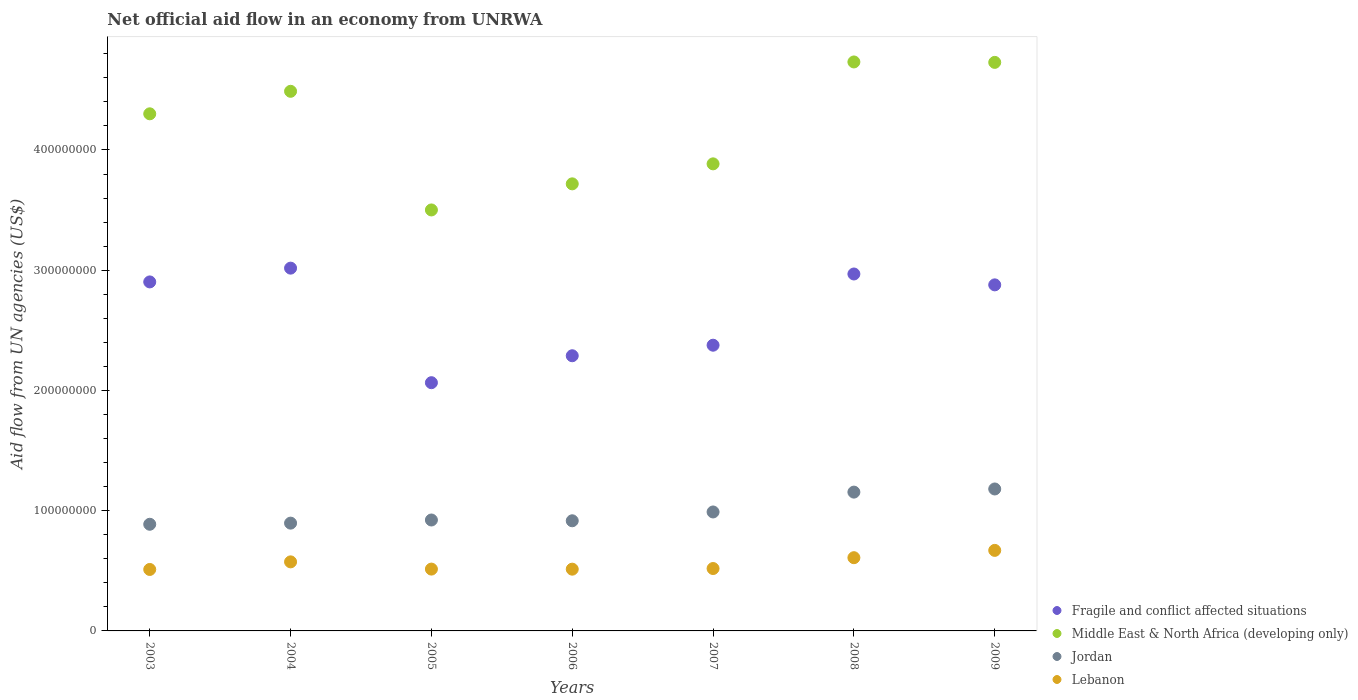What is the net official aid flow in Jordan in 2008?
Offer a terse response. 1.15e+08. Across all years, what is the maximum net official aid flow in Fragile and conflict affected situations?
Your answer should be very brief. 3.02e+08. Across all years, what is the minimum net official aid flow in Jordan?
Keep it short and to the point. 8.87e+07. In which year was the net official aid flow in Jordan maximum?
Keep it short and to the point. 2009. What is the total net official aid flow in Fragile and conflict affected situations in the graph?
Provide a short and direct response. 1.85e+09. What is the difference between the net official aid flow in Middle East & North Africa (developing only) in 2003 and that in 2005?
Ensure brevity in your answer.  8.00e+07. What is the difference between the net official aid flow in Middle East & North Africa (developing only) in 2006 and the net official aid flow in Lebanon in 2005?
Give a very brief answer. 3.20e+08. What is the average net official aid flow in Jordan per year?
Provide a succinct answer. 9.92e+07. In the year 2004, what is the difference between the net official aid flow in Lebanon and net official aid flow in Middle East & North Africa (developing only)?
Your answer should be very brief. -3.91e+08. In how many years, is the net official aid flow in Middle East & North Africa (developing only) greater than 380000000 US$?
Your answer should be compact. 5. What is the ratio of the net official aid flow in Middle East & North Africa (developing only) in 2004 to that in 2009?
Your answer should be compact. 0.95. Is the difference between the net official aid flow in Lebanon in 2003 and 2008 greater than the difference between the net official aid flow in Middle East & North Africa (developing only) in 2003 and 2008?
Make the answer very short. Yes. What is the difference between the highest and the second highest net official aid flow in Middle East & North Africa (developing only)?
Offer a terse response. 3.60e+05. What is the difference between the highest and the lowest net official aid flow in Lebanon?
Keep it short and to the point. 1.59e+07. In how many years, is the net official aid flow in Middle East & North Africa (developing only) greater than the average net official aid flow in Middle East & North Africa (developing only) taken over all years?
Your answer should be very brief. 4. Is it the case that in every year, the sum of the net official aid flow in Fragile and conflict affected situations and net official aid flow in Lebanon  is greater than the sum of net official aid flow in Jordan and net official aid flow in Middle East & North Africa (developing only)?
Make the answer very short. No. Is it the case that in every year, the sum of the net official aid flow in Fragile and conflict affected situations and net official aid flow in Lebanon  is greater than the net official aid flow in Middle East & North Africa (developing only)?
Provide a short and direct response. No. Is the net official aid flow in Lebanon strictly greater than the net official aid flow in Middle East & North Africa (developing only) over the years?
Keep it short and to the point. No. Is the net official aid flow in Middle East & North Africa (developing only) strictly less than the net official aid flow in Lebanon over the years?
Your answer should be very brief. No. How many dotlines are there?
Your answer should be very brief. 4. Are the values on the major ticks of Y-axis written in scientific E-notation?
Ensure brevity in your answer.  No. Does the graph contain any zero values?
Your response must be concise. No. Does the graph contain grids?
Provide a succinct answer. No. Where does the legend appear in the graph?
Offer a very short reply. Bottom right. How many legend labels are there?
Your response must be concise. 4. How are the legend labels stacked?
Offer a very short reply. Vertical. What is the title of the graph?
Provide a short and direct response. Net official aid flow in an economy from UNRWA. Does "Middle East & North Africa (developing only)" appear as one of the legend labels in the graph?
Make the answer very short. Yes. What is the label or title of the Y-axis?
Your response must be concise. Aid flow from UN agencies (US$). What is the Aid flow from UN agencies (US$) in Fragile and conflict affected situations in 2003?
Ensure brevity in your answer.  2.90e+08. What is the Aid flow from UN agencies (US$) in Middle East & North Africa (developing only) in 2003?
Make the answer very short. 4.30e+08. What is the Aid flow from UN agencies (US$) of Jordan in 2003?
Your answer should be compact. 8.87e+07. What is the Aid flow from UN agencies (US$) in Lebanon in 2003?
Your response must be concise. 5.11e+07. What is the Aid flow from UN agencies (US$) of Fragile and conflict affected situations in 2004?
Your response must be concise. 3.02e+08. What is the Aid flow from UN agencies (US$) in Middle East & North Africa (developing only) in 2004?
Provide a short and direct response. 4.49e+08. What is the Aid flow from UN agencies (US$) of Jordan in 2004?
Provide a succinct answer. 8.96e+07. What is the Aid flow from UN agencies (US$) in Lebanon in 2004?
Keep it short and to the point. 5.74e+07. What is the Aid flow from UN agencies (US$) in Fragile and conflict affected situations in 2005?
Ensure brevity in your answer.  2.06e+08. What is the Aid flow from UN agencies (US$) in Middle East & North Africa (developing only) in 2005?
Offer a terse response. 3.50e+08. What is the Aid flow from UN agencies (US$) in Jordan in 2005?
Your answer should be very brief. 9.22e+07. What is the Aid flow from UN agencies (US$) in Lebanon in 2005?
Your answer should be compact. 5.14e+07. What is the Aid flow from UN agencies (US$) of Fragile and conflict affected situations in 2006?
Your response must be concise. 2.29e+08. What is the Aid flow from UN agencies (US$) of Middle East & North Africa (developing only) in 2006?
Your answer should be very brief. 3.72e+08. What is the Aid flow from UN agencies (US$) in Jordan in 2006?
Keep it short and to the point. 9.16e+07. What is the Aid flow from UN agencies (US$) of Lebanon in 2006?
Ensure brevity in your answer.  5.14e+07. What is the Aid flow from UN agencies (US$) in Fragile and conflict affected situations in 2007?
Keep it short and to the point. 2.38e+08. What is the Aid flow from UN agencies (US$) of Middle East & North Africa (developing only) in 2007?
Your answer should be very brief. 3.88e+08. What is the Aid flow from UN agencies (US$) in Jordan in 2007?
Keep it short and to the point. 9.89e+07. What is the Aid flow from UN agencies (US$) in Lebanon in 2007?
Make the answer very short. 5.19e+07. What is the Aid flow from UN agencies (US$) in Fragile and conflict affected situations in 2008?
Your answer should be very brief. 2.97e+08. What is the Aid flow from UN agencies (US$) in Middle East & North Africa (developing only) in 2008?
Make the answer very short. 4.73e+08. What is the Aid flow from UN agencies (US$) of Jordan in 2008?
Keep it short and to the point. 1.15e+08. What is the Aid flow from UN agencies (US$) of Lebanon in 2008?
Your answer should be very brief. 6.09e+07. What is the Aid flow from UN agencies (US$) of Fragile and conflict affected situations in 2009?
Make the answer very short. 2.88e+08. What is the Aid flow from UN agencies (US$) in Middle East & North Africa (developing only) in 2009?
Give a very brief answer. 4.73e+08. What is the Aid flow from UN agencies (US$) of Jordan in 2009?
Offer a terse response. 1.18e+08. What is the Aid flow from UN agencies (US$) in Lebanon in 2009?
Offer a terse response. 6.70e+07. Across all years, what is the maximum Aid flow from UN agencies (US$) in Fragile and conflict affected situations?
Your answer should be compact. 3.02e+08. Across all years, what is the maximum Aid flow from UN agencies (US$) of Middle East & North Africa (developing only)?
Offer a terse response. 4.73e+08. Across all years, what is the maximum Aid flow from UN agencies (US$) in Jordan?
Offer a very short reply. 1.18e+08. Across all years, what is the maximum Aid flow from UN agencies (US$) in Lebanon?
Your answer should be very brief. 6.70e+07. Across all years, what is the minimum Aid flow from UN agencies (US$) in Fragile and conflict affected situations?
Provide a succinct answer. 2.06e+08. Across all years, what is the minimum Aid flow from UN agencies (US$) of Middle East & North Africa (developing only)?
Offer a terse response. 3.50e+08. Across all years, what is the minimum Aid flow from UN agencies (US$) in Jordan?
Your answer should be very brief. 8.87e+07. Across all years, what is the minimum Aid flow from UN agencies (US$) of Lebanon?
Provide a short and direct response. 5.11e+07. What is the total Aid flow from UN agencies (US$) of Fragile and conflict affected situations in the graph?
Provide a succinct answer. 1.85e+09. What is the total Aid flow from UN agencies (US$) of Middle East & North Africa (developing only) in the graph?
Give a very brief answer. 2.94e+09. What is the total Aid flow from UN agencies (US$) of Jordan in the graph?
Offer a terse response. 6.95e+08. What is the total Aid flow from UN agencies (US$) in Lebanon in the graph?
Ensure brevity in your answer.  3.91e+08. What is the difference between the Aid flow from UN agencies (US$) in Fragile and conflict affected situations in 2003 and that in 2004?
Your response must be concise. -1.15e+07. What is the difference between the Aid flow from UN agencies (US$) of Middle East & North Africa (developing only) in 2003 and that in 2004?
Offer a very short reply. -1.87e+07. What is the difference between the Aid flow from UN agencies (US$) in Jordan in 2003 and that in 2004?
Your response must be concise. -9.40e+05. What is the difference between the Aid flow from UN agencies (US$) of Lebanon in 2003 and that in 2004?
Your answer should be compact. -6.32e+06. What is the difference between the Aid flow from UN agencies (US$) of Fragile and conflict affected situations in 2003 and that in 2005?
Provide a short and direct response. 8.38e+07. What is the difference between the Aid flow from UN agencies (US$) of Middle East & North Africa (developing only) in 2003 and that in 2005?
Your response must be concise. 8.00e+07. What is the difference between the Aid flow from UN agencies (US$) in Jordan in 2003 and that in 2005?
Offer a very short reply. -3.55e+06. What is the difference between the Aid flow from UN agencies (US$) of Lebanon in 2003 and that in 2005?
Your answer should be very brief. -3.10e+05. What is the difference between the Aid flow from UN agencies (US$) in Fragile and conflict affected situations in 2003 and that in 2006?
Provide a short and direct response. 6.14e+07. What is the difference between the Aid flow from UN agencies (US$) of Middle East & North Africa (developing only) in 2003 and that in 2006?
Your answer should be compact. 5.82e+07. What is the difference between the Aid flow from UN agencies (US$) of Jordan in 2003 and that in 2006?
Offer a terse response. -2.90e+06. What is the difference between the Aid flow from UN agencies (US$) of Lebanon in 2003 and that in 2006?
Provide a succinct answer. -2.50e+05. What is the difference between the Aid flow from UN agencies (US$) of Fragile and conflict affected situations in 2003 and that in 2007?
Give a very brief answer. 5.26e+07. What is the difference between the Aid flow from UN agencies (US$) of Middle East & North Africa (developing only) in 2003 and that in 2007?
Your answer should be very brief. 4.16e+07. What is the difference between the Aid flow from UN agencies (US$) in Jordan in 2003 and that in 2007?
Your answer should be very brief. -1.02e+07. What is the difference between the Aid flow from UN agencies (US$) in Lebanon in 2003 and that in 2007?
Make the answer very short. -7.80e+05. What is the difference between the Aid flow from UN agencies (US$) of Fragile and conflict affected situations in 2003 and that in 2008?
Give a very brief answer. -6.60e+06. What is the difference between the Aid flow from UN agencies (US$) of Middle East & North Africa (developing only) in 2003 and that in 2008?
Offer a terse response. -4.31e+07. What is the difference between the Aid flow from UN agencies (US$) in Jordan in 2003 and that in 2008?
Your answer should be very brief. -2.67e+07. What is the difference between the Aid flow from UN agencies (US$) in Lebanon in 2003 and that in 2008?
Offer a very short reply. -9.79e+06. What is the difference between the Aid flow from UN agencies (US$) in Fragile and conflict affected situations in 2003 and that in 2009?
Make the answer very short. 2.45e+06. What is the difference between the Aid flow from UN agencies (US$) of Middle East & North Africa (developing only) in 2003 and that in 2009?
Offer a terse response. -4.28e+07. What is the difference between the Aid flow from UN agencies (US$) of Jordan in 2003 and that in 2009?
Keep it short and to the point. -2.94e+07. What is the difference between the Aid flow from UN agencies (US$) in Lebanon in 2003 and that in 2009?
Your response must be concise. -1.59e+07. What is the difference between the Aid flow from UN agencies (US$) in Fragile and conflict affected situations in 2004 and that in 2005?
Give a very brief answer. 9.53e+07. What is the difference between the Aid flow from UN agencies (US$) of Middle East & North Africa (developing only) in 2004 and that in 2005?
Your answer should be very brief. 9.87e+07. What is the difference between the Aid flow from UN agencies (US$) of Jordan in 2004 and that in 2005?
Your response must be concise. -2.61e+06. What is the difference between the Aid flow from UN agencies (US$) of Lebanon in 2004 and that in 2005?
Your answer should be very brief. 6.01e+06. What is the difference between the Aid flow from UN agencies (US$) in Fragile and conflict affected situations in 2004 and that in 2006?
Ensure brevity in your answer.  7.29e+07. What is the difference between the Aid flow from UN agencies (US$) of Middle East & North Africa (developing only) in 2004 and that in 2006?
Provide a succinct answer. 7.70e+07. What is the difference between the Aid flow from UN agencies (US$) of Jordan in 2004 and that in 2006?
Your answer should be compact. -1.96e+06. What is the difference between the Aid flow from UN agencies (US$) of Lebanon in 2004 and that in 2006?
Ensure brevity in your answer.  6.07e+06. What is the difference between the Aid flow from UN agencies (US$) in Fragile and conflict affected situations in 2004 and that in 2007?
Give a very brief answer. 6.41e+07. What is the difference between the Aid flow from UN agencies (US$) of Middle East & North Africa (developing only) in 2004 and that in 2007?
Ensure brevity in your answer.  6.03e+07. What is the difference between the Aid flow from UN agencies (US$) of Jordan in 2004 and that in 2007?
Your response must be concise. -9.29e+06. What is the difference between the Aid flow from UN agencies (US$) in Lebanon in 2004 and that in 2007?
Offer a very short reply. 5.54e+06. What is the difference between the Aid flow from UN agencies (US$) in Fragile and conflict affected situations in 2004 and that in 2008?
Offer a terse response. 4.86e+06. What is the difference between the Aid flow from UN agencies (US$) of Middle East & North Africa (developing only) in 2004 and that in 2008?
Offer a very short reply. -2.44e+07. What is the difference between the Aid flow from UN agencies (US$) in Jordan in 2004 and that in 2008?
Offer a terse response. -2.58e+07. What is the difference between the Aid flow from UN agencies (US$) of Lebanon in 2004 and that in 2008?
Make the answer very short. -3.47e+06. What is the difference between the Aid flow from UN agencies (US$) of Fragile and conflict affected situations in 2004 and that in 2009?
Provide a short and direct response. 1.39e+07. What is the difference between the Aid flow from UN agencies (US$) in Middle East & North Africa (developing only) in 2004 and that in 2009?
Provide a succinct answer. -2.40e+07. What is the difference between the Aid flow from UN agencies (US$) of Jordan in 2004 and that in 2009?
Make the answer very short. -2.84e+07. What is the difference between the Aid flow from UN agencies (US$) of Lebanon in 2004 and that in 2009?
Offer a very short reply. -9.55e+06. What is the difference between the Aid flow from UN agencies (US$) in Fragile and conflict affected situations in 2005 and that in 2006?
Keep it short and to the point. -2.24e+07. What is the difference between the Aid flow from UN agencies (US$) of Middle East & North Africa (developing only) in 2005 and that in 2006?
Offer a terse response. -2.17e+07. What is the difference between the Aid flow from UN agencies (US$) in Jordan in 2005 and that in 2006?
Provide a succinct answer. 6.50e+05. What is the difference between the Aid flow from UN agencies (US$) of Lebanon in 2005 and that in 2006?
Your answer should be very brief. 6.00e+04. What is the difference between the Aid flow from UN agencies (US$) in Fragile and conflict affected situations in 2005 and that in 2007?
Your response must be concise. -3.12e+07. What is the difference between the Aid flow from UN agencies (US$) in Middle East & North Africa (developing only) in 2005 and that in 2007?
Ensure brevity in your answer.  -3.83e+07. What is the difference between the Aid flow from UN agencies (US$) in Jordan in 2005 and that in 2007?
Give a very brief answer. -6.68e+06. What is the difference between the Aid flow from UN agencies (US$) of Lebanon in 2005 and that in 2007?
Ensure brevity in your answer.  -4.70e+05. What is the difference between the Aid flow from UN agencies (US$) of Fragile and conflict affected situations in 2005 and that in 2008?
Offer a very short reply. -9.04e+07. What is the difference between the Aid flow from UN agencies (US$) of Middle East & North Africa (developing only) in 2005 and that in 2008?
Your answer should be very brief. -1.23e+08. What is the difference between the Aid flow from UN agencies (US$) of Jordan in 2005 and that in 2008?
Offer a very short reply. -2.32e+07. What is the difference between the Aid flow from UN agencies (US$) in Lebanon in 2005 and that in 2008?
Ensure brevity in your answer.  -9.48e+06. What is the difference between the Aid flow from UN agencies (US$) of Fragile and conflict affected situations in 2005 and that in 2009?
Offer a terse response. -8.14e+07. What is the difference between the Aid flow from UN agencies (US$) in Middle East & North Africa (developing only) in 2005 and that in 2009?
Your response must be concise. -1.23e+08. What is the difference between the Aid flow from UN agencies (US$) of Jordan in 2005 and that in 2009?
Provide a succinct answer. -2.58e+07. What is the difference between the Aid flow from UN agencies (US$) in Lebanon in 2005 and that in 2009?
Provide a short and direct response. -1.56e+07. What is the difference between the Aid flow from UN agencies (US$) of Fragile and conflict affected situations in 2006 and that in 2007?
Your answer should be compact. -8.77e+06. What is the difference between the Aid flow from UN agencies (US$) of Middle East & North Africa (developing only) in 2006 and that in 2007?
Your response must be concise. -1.66e+07. What is the difference between the Aid flow from UN agencies (US$) in Jordan in 2006 and that in 2007?
Make the answer very short. -7.33e+06. What is the difference between the Aid flow from UN agencies (US$) of Lebanon in 2006 and that in 2007?
Provide a succinct answer. -5.30e+05. What is the difference between the Aid flow from UN agencies (US$) of Fragile and conflict affected situations in 2006 and that in 2008?
Your response must be concise. -6.80e+07. What is the difference between the Aid flow from UN agencies (US$) in Middle East & North Africa (developing only) in 2006 and that in 2008?
Give a very brief answer. -1.01e+08. What is the difference between the Aid flow from UN agencies (US$) in Jordan in 2006 and that in 2008?
Keep it short and to the point. -2.38e+07. What is the difference between the Aid flow from UN agencies (US$) in Lebanon in 2006 and that in 2008?
Your response must be concise. -9.54e+06. What is the difference between the Aid flow from UN agencies (US$) in Fragile and conflict affected situations in 2006 and that in 2009?
Offer a very short reply. -5.90e+07. What is the difference between the Aid flow from UN agencies (US$) of Middle East & North Africa (developing only) in 2006 and that in 2009?
Keep it short and to the point. -1.01e+08. What is the difference between the Aid flow from UN agencies (US$) in Jordan in 2006 and that in 2009?
Offer a very short reply. -2.64e+07. What is the difference between the Aid flow from UN agencies (US$) in Lebanon in 2006 and that in 2009?
Your answer should be compact. -1.56e+07. What is the difference between the Aid flow from UN agencies (US$) in Fragile and conflict affected situations in 2007 and that in 2008?
Offer a very short reply. -5.92e+07. What is the difference between the Aid flow from UN agencies (US$) of Middle East & North Africa (developing only) in 2007 and that in 2008?
Your answer should be very brief. -8.48e+07. What is the difference between the Aid flow from UN agencies (US$) of Jordan in 2007 and that in 2008?
Make the answer very short. -1.65e+07. What is the difference between the Aid flow from UN agencies (US$) of Lebanon in 2007 and that in 2008?
Offer a very short reply. -9.01e+06. What is the difference between the Aid flow from UN agencies (US$) in Fragile and conflict affected situations in 2007 and that in 2009?
Provide a short and direct response. -5.02e+07. What is the difference between the Aid flow from UN agencies (US$) in Middle East & North Africa (developing only) in 2007 and that in 2009?
Offer a very short reply. -8.44e+07. What is the difference between the Aid flow from UN agencies (US$) of Jordan in 2007 and that in 2009?
Keep it short and to the point. -1.91e+07. What is the difference between the Aid flow from UN agencies (US$) of Lebanon in 2007 and that in 2009?
Give a very brief answer. -1.51e+07. What is the difference between the Aid flow from UN agencies (US$) in Fragile and conflict affected situations in 2008 and that in 2009?
Your answer should be very brief. 9.05e+06. What is the difference between the Aid flow from UN agencies (US$) in Jordan in 2008 and that in 2009?
Provide a short and direct response. -2.61e+06. What is the difference between the Aid flow from UN agencies (US$) in Lebanon in 2008 and that in 2009?
Ensure brevity in your answer.  -6.08e+06. What is the difference between the Aid flow from UN agencies (US$) of Fragile and conflict affected situations in 2003 and the Aid flow from UN agencies (US$) of Middle East & North Africa (developing only) in 2004?
Your response must be concise. -1.59e+08. What is the difference between the Aid flow from UN agencies (US$) in Fragile and conflict affected situations in 2003 and the Aid flow from UN agencies (US$) in Jordan in 2004?
Ensure brevity in your answer.  2.01e+08. What is the difference between the Aid flow from UN agencies (US$) of Fragile and conflict affected situations in 2003 and the Aid flow from UN agencies (US$) of Lebanon in 2004?
Ensure brevity in your answer.  2.33e+08. What is the difference between the Aid flow from UN agencies (US$) in Middle East & North Africa (developing only) in 2003 and the Aid flow from UN agencies (US$) in Jordan in 2004?
Keep it short and to the point. 3.40e+08. What is the difference between the Aid flow from UN agencies (US$) of Middle East & North Africa (developing only) in 2003 and the Aid flow from UN agencies (US$) of Lebanon in 2004?
Offer a very short reply. 3.73e+08. What is the difference between the Aid flow from UN agencies (US$) of Jordan in 2003 and the Aid flow from UN agencies (US$) of Lebanon in 2004?
Provide a short and direct response. 3.13e+07. What is the difference between the Aid flow from UN agencies (US$) of Fragile and conflict affected situations in 2003 and the Aid flow from UN agencies (US$) of Middle East & North Africa (developing only) in 2005?
Ensure brevity in your answer.  -5.99e+07. What is the difference between the Aid flow from UN agencies (US$) of Fragile and conflict affected situations in 2003 and the Aid flow from UN agencies (US$) of Jordan in 2005?
Your response must be concise. 1.98e+08. What is the difference between the Aid flow from UN agencies (US$) in Fragile and conflict affected situations in 2003 and the Aid flow from UN agencies (US$) in Lebanon in 2005?
Offer a terse response. 2.39e+08. What is the difference between the Aid flow from UN agencies (US$) of Middle East & North Africa (developing only) in 2003 and the Aid flow from UN agencies (US$) of Jordan in 2005?
Make the answer very short. 3.38e+08. What is the difference between the Aid flow from UN agencies (US$) in Middle East & North Africa (developing only) in 2003 and the Aid flow from UN agencies (US$) in Lebanon in 2005?
Keep it short and to the point. 3.79e+08. What is the difference between the Aid flow from UN agencies (US$) in Jordan in 2003 and the Aid flow from UN agencies (US$) in Lebanon in 2005?
Offer a very short reply. 3.73e+07. What is the difference between the Aid flow from UN agencies (US$) in Fragile and conflict affected situations in 2003 and the Aid flow from UN agencies (US$) in Middle East & North Africa (developing only) in 2006?
Offer a terse response. -8.16e+07. What is the difference between the Aid flow from UN agencies (US$) in Fragile and conflict affected situations in 2003 and the Aid flow from UN agencies (US$) in Jordan in 2006?
Ensure brevity in your answer.  1.99e+08. What is the difference between the Aid flow from UN agencies (US$) in Fragile and conflict affected situations in 2003 and the Aid flow from UN agencies (US$) in Lebanon in 2006?
Provide a short and direct response. 2.39e+08. What is the difference between the Aid flow from UN agencies (US$) in Middle East & North Africa (developing only) in 2003 and the Aid flow from UN agencies (US$) in Jordan in 2006?
Keep it short and to the point. 3.38e+08. What is the difference between the Aid flow from UN agencies (US$) of Middle East & North Africa (developing only) in 2003 and the Aid flow from UN agencies (US$) of Lebanon in 2006?
Your answer should be compact. 3.79e+08. What is the difference between the Aid flow from UN agencies (US$) in Jordan in 2003 and the Aid flow from UN agencies (US$) in Lebanon in 2006?
Make the answer very short. 3.73e+07. What is the difference between the Aid flow from UN agencies (US$) in Fragile and conflict affected situations in 2003 and the Aid flow from UN agencies (US$) in Middle East & North Africa (developing only) in 2007?
Your answer should be compact. -9.82e+07. What is the difference between the Aid flow from UN agencies (US$) of Fragile and conflict affected situations in 2003 and the Aid flow from UN agencies (US$) of Jordan in 2007?
Give a very brief answer. 1.91e+08. What is the difference between the Aid flow from UN agencies (US$) of Fragile and conflict affected situations in 2003 and the Aid flow from UN agencies (US$) of Lebanon in 2007?
Ensure brevity in your answer.  2.38e+08. What is the difference between the Aid flow from UN agencies (US$) in Middle East & North Africa (developing only) in 2003 and the Aid flow from UN agencies (US$) in Jordan in 2007?
Offer a very short reply. 3.31e+08. What is the difference between the Aid flow from UN agencies (US$) in Middle East & North Africa (developing only) in 2003 and the Aid flow from UN agencies (US$) in Lebanon in 2007?
Give a very brief answer. 3.78e+08. What is the difference between the Aid flow from UN agencies (US$) in Jordan in 2003 and the Aid flow from UN agencies (US$) in Lebanon in 2007?
Offer a very short reply. 3.68e+07. What is the difference between the Aid flow from UN agencies (US$) in Fragile and conflict affected situations in 2003 and the Aid flow from UN agencies (US$) in Middle East & North Africa (developing only) in 2008?
Keep it short and to the point. -1.83e+08. What is the difference between the Aid flow from UN agencies (US$) of Fragile and conflict affected situations in 2003 and the Aid flow from UN agencies (US$) of Jordan in 2008?
Your response must be concise. 1.75e+08. What is the difference between the Aid flow from UN agencies (US$) in Fragile and conflict affected situations in 2003 and the Aid flow from UN agencies (US$) in Lebanon in 2008?
Your answer should be very brief. 2.29e+08. What is the difference between the Aid flow from UN agencies (US$) of Middle East & North Africa (developing only) in 2003 and the Aid flow from UN agencies (US$) of Jordan in 2008?
Give a very brief answer. 3.15e+08. What is the difference between the Aid flow from UN agencies (US$) of Middle East & North Africa (developing only) in 2003 and the Aid flow from UN agencies (US$) of Lebanon in 2008?
Your answer should be compact. 3.69e+08. What is the difference between the Aid flow from UN agencies (US$) of Jordan in 2003 and the Aid flow from UN agencies (US$) of Lebanon in 2008?
Offer a terse response. 2.78e+07. What is the difference between the Aid flow from UN agencies (US$) in Fragile and conflict affected situations in 2003 and the Aid flow from UN agencies (US$) in Middle East & North Africa (developing only) in 2009?
Your answer should be compact. -1.83e+08. What is the difference between the Aid flow from UN agencies (US$) in Fragile and conflict affected situations in 2003 and the Aid flow from UN agencies (US$) in Jordan in 2009?
Provide a succinct answer. 1.72e+08. What is the difference between the Aid flow from UN agencies (US$) in Fragile and conflict affected situations in 2003 and the Aid flow from UN agencies (US$) in Lebanon in 2009?
Ensure brevity in your answer.  2.23e+08. What is the difference between the Aid flow from UN agencies (US$) in Middle East & North Africa (developing only) in 2003 and the Aid flow from UN agencies (US$) in Jordan in 2009?
Make the answer very short. 3.12e+08. What is the difference between the Aid flow from UN agencies (US$) in Middle East & North Africa (developing only) in 2003 and the Aid flow from UN agencies (US$) in Lebanon in 2009?
Provide a short and direct response. 3.63e+08. What is the difference between the Aid flow from UN agencies (US$) in Jordan in 2003 and the Aid flow from UN agencies (US$) in Lebanon in 2009?
Your answer should be compact. 2.17e+07. What is the difference between the Aid flow from UN agencies (US$) of Fragile and conflict affected situations in 2004 and the Aid flow from UN agencies (US$) of Middle East & North Africa (developing only) in 2005?
Provide a succinct answer. -4.84e+07. What is the difference between the Aid flow from UN agencies (US$) in Fragile and conflict affected situations in 2004 and the Aid flow from UN agencies (US$) in Jordan in 2005?
Your answer should be very brief. 2.09e+08. What is the difference between the Aid flow from UN agencies (US$) in Fragile and conflict affected situations in 2004 and the Aid flow from UN agencies (US$) in Lebanon in 2005?
Keep it short and to the point. 2.50e+08. What is the difference between the Aid flow from UN agencies (US$) in Middle East & North Africa (developing only) in 2004 and the Aid flow from UN agencies (US$) in Jordan in 2005?
Give a very brief answer. 3.57e+08. What is the difference between the Aid flow from UN agencies (US$) in Middle East & North Africa (developing only) in 2004 and the Aid flow from UN agencies (US$) in Lebanon in 2005?
Offer a terse response. 3.97e+08. What is the difference between the Aid flow from UN agencies (US$) of Jordan in 2004 and the Aid flow from UN agencies (US$) of Lebanon in 2005?
Give a very brief answer. 3.82e+07. What is the difference between the Aid flow from UN agencies (US$) in Fragile and conflict affected situations in 2004 and the Aid flow from UN agencies (US$) in Middle East & North Africa (developing only) in 2006?
Provide a short and direct response. -7.01e+07. What is the difference between the Aid flow from UN agencies (US$) in Fragile and conflict affected situations in 2004 and the Aid flow from UN agencies (US$) in Jordan in 2006?
Ensure brevity in your answer.  2.10e+08. What is the difference between the Aid flow from UN agencies (US$) in Fragile and conflict affected situations in 2004 and the Aid flow from UN agencies (US$) in Lebanon in 2006?
Keep it short and to the point. 2.50e+08. What is the difference between the Aid flow from UN agencies (US$) of Middle East & North Africa (developing only) in 2004 and the Aid flow from UN agencies (US$) of Jordan in 2006?
Offer a terse response. 3.57e+08. What is the difference between the Aid flow from UN agencies (US$) of Middle East & North Africa (developing only) in 2004 and the Aid flow from UN agencies (US$) of Lebanon in 2006?
Your answer should be compact. 3.97e+08. What is the difference between the Aid flow from UN agencies (US$) in Jordan in 2004 and the Aid flow from UN agencies (US$) in Lebanon in 2006?
Give a very brief answer. 3.83e+07. What is the difference between the Aid flow from UN agencies (US$) of Fragile and conflict affected situations in 2004 and the Aid flow from UN agencies (US$) of Middle East & North Africa (developing only) in 2007?
Ensure brevity in your answer.  -8.67e+07. What is the difference between the Aid flow from UN agencies (US$) in Fragile and conflict affected situations in 2004 and the Aid flow from UN agencies (US$) in Jordan in 2007?
Offer a terse response. 2.03e+08. What is the difference between the Aid flow from UN agencies (US$) of Fragile and conflict affected situations in 2004 and the Aid flow from UN agencies (US$) of Lebanon in 2007?
Your response must be concise. 2.50e+08. What is the difference between the Aid flow from UN agencies (US$) of Middle East & North Africa (developing only) in 2004 and the Aid flow from UN agencies (US$) of Jordan in 2007?
Ensure brevity in your answer.  3.50e+08. What is the difference between the Aid flow from UN agencies (US$) in Middle East & North Africa (developing only) in 2004 and the Aid flow from UN agencies (US$) in Lebanon in 2007?
Your answer should be compact. 3.97e+08. What is the difference between the Aid flow from UN agencies (US$) in Jordan in 2004 and the Aid flow from UN agencies (US$) in Lebanon in 2007?
Offer a terse response. 3.78e+07. What is the difference between the Aid flow from UN agencies (US$) of Fragile and conflict affected situations in 2004 and the Aid flow from UN agencies (US$) of Middle East & North Africa (developing only) in 2008?
Provide a succinct answer. -1.71e+08. What is the difference between the Aid flow from UN agencies (US$) of Fragile and conflict affected situations in 2004 and the Aid flow from UN agencies (US$) of Jordan in 2008?
Your answer should be compact. 1.86e+08. What is the difference between the Aid flow from UN agencies (US$) of Fragile and conflict affected situations in 2004 and the Aid flow from UN agencies (US$) of Lebanon in 2008?
Provide a succinct answer. 2.41e+08. What is the difference between the Aid flow from UN agencies (US$) of Middle East & North Africa (developing only) in 2004 and the Aid flow from UN agencies (US$) of Jordan in 2008?
Provide a succinct answer. 3.33e+08. What is the difference between the Aid flow from UN agencies (US$) of Middle East & North Africa (developing only) in 2004 and the Aid flow from UN agencies (US$) of Lebanon in 2008?
Offer a very short reply. 3.88e+08. What is the difference between the Aid flow from UN agencies (US$) in Jordan in 2004 and the Aid flow from UN agencies (US$) in Lebanon in 2008?
Ensure brevity in your answer.  2.87e+07. What is the difference between the Aid flow from UN agencies (US$) of Fragile and conflict affected situations in 2004 and the Aid flow from UN agencies (US$) of Middle East & North Africa (developing only) in 2009?
Your response must be concise. -1.71e+08. What is the difference between the Aid flow from UN agencies (US$) in Fragile and conflict affected situations in 2004 and the Aid flow from UN agencies (US$) in Jordan in 2009?
Keep it short and to the point. 1.84e+08. What is the difference between the Aid flow from UN agencies (US$) of Fragile and conflict affected situations in 2004 and the Aid flow from UN agencies (US$) of Lebanon in 2009?
Give a very brief answer. 2.35e+08. What is the difference between the Aid flow from UN agencies (US$) of Middle East & North Africa (developing only) in 2004 and the Aid flow from UN agencies (US$) of Jordan in 2009?
Keep it short and to the point. 3.31e+08. What is the difference between the Aid flow from UN agencies (US$) of Middle East & North Africa (developing only) in 2004 and the Aid flow from UN agencies (US$) of Lebanon in 2009?
Make the answer very short. 3.82e+08. What is the difference between the Aid flow from UN agencies (US$) in Jordan in 2004 and the Aid flow from UN agencies (US$) in Lebanon in 2009?
Offer a very short reply. 2.27e+07. What is the difference between the Aid flow from UN agencies (US$) of Fragile and conflict affected situations in 2005 and the Aid flow from UN agencies (US$) of Middle East & North Africa (developing only) in 2006?
Offer a very short reply. -1.65e+08. What is the difference between the Aid flow from UN agencies (US$) in Fragile and conflict affected situations in 2005 and the Aid flow from UN agencies (US$) in Jordan in 2006?
Give a very brief answer. 1.15e+08. What is the difference between the Aid flow from UN agencies (US$) in Fragile and conflict affected situations in 2005 and the Aid flow from UN agencies (US$) in Lebanon in 2006?
Your answer should be compact. 1.55e+08. What is the difference between the Aid flow from UN agencies (US$) in Middle East & North Africa (developing only) in 2005 and the Aid flow from UN agencies (US$) in Jordan in 2006?
Your answer should be compact. 2.59e+08. What is the difference between the Aid flow from UN agencies (US$) in Middle East & North Africa (developing only) in 2005 and the Aid flow from UN agencies (US$) in Lebanon in 2006?
Keep it short and to the point. 2.99e+08. What is the difference between the Aid flow from UN agencies (US$) in Jordan in 2005 and the Aid flow from UN agencies (US$) in Lebanon in 2006?
Keep it short and to the point. 4.09e+07. What is the difference between the Aid flow from UN agencies (US$) of Fragile and conflict affected situations in 2005 and the Aid flow from UN agencies (US$) of Middle East & North Africa (developing only) in 2007?
Keep it short and to the point. -1.82e+08. What is the difference between the Aid flow from UN agencies (US$) of Fragile and conflict affected situations in 2005 and the Aid flow from UN agencies (US$) of Jordan in 2007?
Your answer should be very brief. 1.08e+08. What is the difference between the Aid flow from UN agencies (US$) in Fragile and conflict affected situations in 2005 and the Aid flow from UN agencies (US$) in Lebanon in 2007?
Provide a short and direct response. 1.55e+08. What is the difference between the Aid flow from UN agencies (US$) in Middle East & North Africa (developing only) in 2005 and the Aid flow from UN agencies (US$) in Jordan in 2007?
Your response must be concise. 2.51e+08. What is the difference between the Aid flow from UN agencies (US$) of Middle East & North Africa (developing only) in 2005 and the Aid flow from UN agencies (US$) of Lebanon in 2007?
Provide a succinct answer. 2.98e+08. What is the difference between the Aid flow from UN agencies (US$) in Jordan in 2005 and the Aid flow from UN agencies (US$) in Lebanon in 2007?
Provide a short and direct response. 4.04e+07. What is the difference between the Aid flow from UN agencies (US$) in Fragile and conflict affected situations in 2005 and the Aid flow from UN agencies (US$) in Middle East & North Africa (developing only) in 2008?
Your answer should be compact. -2.67e+08. What is the difference between the Aid flow from UN agencies (US$) of Fragile and conflict affected situations in 2005 and the Aid flow from UN agencies (US$) of Jordan in 2008?
Your response must be concise. 9.10e+07. What is the difference between the Aid flow from UN agencies (US$) of Fragile and conflict affected situations in 2005 and the Aid flow from UN agencies (US$) of Lebanon in 2008?
Your answer should be very brief. 1.46e+08. What is the difference between the Aid flow from UN agencies (US$) of Middle East & North Africa (developing only) in 2005 and the Aid flow from UN agencies (US$) of Jordan in 2008?
Keep it short and to the point. 2.35e+08. What is the difference between the Aid flow from UN agencies (US$) of Middle East & North Africa (developing only) in 2005 and the Aid flow from UN agencies (US$) of Lebanon in 2008?
Provide a succinct answer. 2.89e+08. What is the difference between the Aid flow from UN agencies (US$) of Jordan in 2005 and the Aid flow from UN agencies (US$) of Lebanon in 2008?
Your response must be concise. 3.14e+07. What is the difference between the Aid flow from UN agencies (US$) in Fragile and conflict affected situations in 2005 and the Aid flow from UN agencies (US$) in Middle East & North Africa (developing only) in 2009?
Your answer should be compact. -2.66e+08. What is the difference between the Aid flow from UN agencies (US$) in Fragile and conflict affected situations in 2005 and the Aid flow from UN agencies (US$) in Jordan in 2009?
Provide a short and direct response. 8.84e+07. What is the difference between the Aid flow from UN agencies (US$) in Fragile and conflict affected situations in 2005 and the Aid flow from UN agencies (US$) in Lebanon in 2009?
Your answer should be very brief. 1.39e+08. What is the difference between the Aid flow from UN agencies (US$) of Middle East & North Africa (developing only) in 2005 and the Aid flow from UN agencies (US$) of Jordan in 2009?
Your response must be concise. 2.32e+08. What is the difference between the Aid flow from UN agencies (US$) in Middle East & North Africa (developing only) in 2005 and the Aid flow from UN agencies (US$) in Lebanon in 2009?
Offer a terse response. 2.83e+08. What is the difference between the Aid flow from UN agencies (US$) of Jordan in 2005 and the Aid flow from UN agencies (US$) of Lebanon in 2009?
Ensure brevity in your answer.  2.53e+07. What is the difference between the Aid flow from UN agencies (US$) in Fragile and conflict affected situations in 2006 and the Aid flow from UN agencies (US$) in Middle East & North Africa (developing only) in 2007?
Offer a terse response. -1.60e+08. What is the difference between the Aid flow from UN agencies (US$) in Fragile and conflict affected situations in 2006 and the Aid flow from UN agencies (US$) in Jordan in 2007?
Provide a short and direct response. 1.30e+08. What is the difference between the Aid flow from UN agencies (US$) of Fragile and conflict affected situations in 2006 and the Aid flow from UN agencies (US$) of Lebanon in 2007?
Provide a succinct answer. 1.77e+08. What is the difference between the Aid flow from UN agencies (US$) of Middle East & North Africa (developing only) in 2006 and the Aid flow from UN agencies (US$) of Jordan in 2007?
Your response must be concise. 2.73e+08. What is the difference between the Aid flow from UN agencies (US$) of Middle East & North Africa (developing only) in 2006 and the Aid flow from UN agencies (US$) of Lebanon in 2007?
Provide a short and direct response. 3.20e+08. What is the difference between the Aid flow from UN agencies (US$) in Jordan in 2006 and the Aid flow from UN agencies (US$) in Lebanon in 2007?
Keep it short and to the point. 3.97e+07. What is the difference between the Aid flow from UN agencies (US$) in Fragile and conflict affected situations in 2006 and the Aid flow from UN agencies (US$) in Middle East & North Africa (developing only) in 2008?
Your answer should be very brief. -2.44e+08. What is the difference between the Aid flow from UN agencies (US$) in Fragile and conflict affected situations in 2006 and the Aid flow from UN agencies (US$) in Jordan in 2008?
Provide a succinct answer. 1.13e+08. What is the difference between the Aid flow from UN agencies (US$) of Fragile and conflict affected situations in 2006 and the Aid flow from UN agencies (US$) of Lebanon in 2008?
Provide a short and direct response. 1.68e+08. What is the difference between the Aid flow from UN agencies (US$) of Middle East & North Africa (developing only) in 2006 and the Aid flow from UN agencies (US$) of Jordan in 2008?
Your answer should be very brief. 2.56e+08. What is the difference between the Aid flow from UN agencies (US$) of Middle East & North Africa (developing only) in 2006 and the Aid flow from UN agencies (US$) of Lebanon in 2008?
Offer a very short reply. 3.11e+08. What is the difference between the Aid flow from UN agencies (US$) of Jordan in 2006 and the Aid flow from UN agencies (US$) of Lebanon in 2008?
Offer a terse response. 3.07e+07. What is the difference between the Aid flow from UN agencies (US$) in Fragile and conflict affected situations in 2006 and the Aid flow from UN agencies (US$) in Middle East & North Africa (developing only) in 2009?
Offer a terse response. -2.44e+08. What is the difference between the Aid flow from UN agencies (US$) of Fragile and conflict affected situations in 2006 and the Aid flow from UN agencies (US$) of Jordan in 2009?
Offer a very short reply. 1.11e+08. What is the difference between the Aid flow from UN agencies (US$) in Fragile and conflict affected situations in 2006 and the Aid flow from UN agencies (US$) in Lebanon in 2009?
Your response must be concise. 1.62e+08. What is the difference between the Aid flow from UN agencies (US$) in Middle East & North Africa (developing only) in 2006 and the Aid flow from UN agencies (US$) in Jordan in 2009?
Offer a terse response. 2.54e+08. What is the difference between the Aid flow from UN agencies (US$) in Middle East & North Africa (developing only) in 2006 and the Aid flow from UN agencies (US$) in Lebanon in 2009?
Your response must be concise. 3.05e+08. What is the difference between the Aid flow from UN agencies (US$) of Jordan in 2006 and the Aid flow from UN agencies (US$) of Lebanon in 2009?
Keep it short and to the point. 2.46e+07. What is the difference between the Aid flow from UN agencies (US$) of Fragile and conflict affected situations in 2007 and the Aid flow from UN agencies (US$) of Middle East & North Africa (developing only) in 2008?
Make the answer very short. -2.36e+08. What is the difference between the Aid flow from UN agencies (US$) of Fragile and conflict affected situations in 2007 and the Aid flow from UN agencies (US$) of Jordan in 2008?
Make the answer very short. 1.22e+08. What is the difference between the Aid flow from UN agencies (US$) in Fragile and conflict affected situations in 2007 and the Aid flow from UN agencies (US$) in Lebanon in 2008?
Your response must be concise. 1.77e+08. What is the difference between the Aid flow from UN agencies (US$) of Middle East & North Africa (developing only) in 2007 and the Aid flow from UN agencies (US$) of Jordan in 2008?
Offer a very short reply. 2.73e+08. What is the difference between the Aid flow from UN agencies (US$) in Middle East & North Africa (developing only) in 2007 and the Aid flow from UN agencies (US$) in Lebanon in 2008?
Ensure brevity in your answer.  3.28e+08. What is the difference between the Aid flow from UN agencies (US$) in Jordan in 2007 and the Aid flow from UN agencies (US$) in Lebanon in 2008?
Provide a short and direct response. 3.80e+07. What is the difference between the Aid flow from UN agencies (US$) in Fragile and conflict affected situations in 2007 and the Aid flow from UN agencies (US$) in Middle East & North Africa (developing only) in 2009?
Your answer should be compact. -2.35e+08. What is the difference between the Aid flow from UN agencies (US$) of Fragile and conflict affected situations in 2007 and the Aid flow from UN agencies (US$) of Jordan in 2009?
Ensure brevity in your answer.  1.20e+08. What is the difference between the Aid flow from UN agencies (US$) in Fragile and conflict affected situations in 2007 and the Aid flow from UN agencies (US$) in Lebanon in 2009?
Make the answer very short. 1.71e+08. What is the difference between the Aid flow from UN agencies (US$) of Middle East & North Africa (developing only) in 2007 and the Aid flow from UN agencies (US$) of Jordan in 2009?
Offer a very short reply. 2.70e+08. What is the difference between the Aid flow from UN agencies (US$) in Middle East & North Africa (developing only) in 2007 and the Aid flow from UN agencies (US$) in Lebanon in 2009?
Offer a terse response. 3.21e+08. What is the difference between the Aid flow from UN agencies (US$) in Jordan in 2007 and the Aid flow from UN agencies (US$) in Lebanon in 2009?
Make the answer very short. 3.20e+07. What is the difference between the Aid flow from UN agencies (US$) of Fragile and conflict affected situations in 2008 and the Aid flow from UN agencies (US$) of Middle East & North Africa (developing only) in 2009?
Your response must be concise. -1.76e+08. What is the difference between the Aid flow from UN agencies (US$) in Fragile and conflict affected situations in 2008 and the Aid flow from UN agencies (US$) in Jordan in 2009?
Provide a succinct answer. 1.79e+08. What is the difference between the Aid flow from UN agencies (US$) of Fragile and conflict affected situations in 2008 and the Aid flow from UN agencies (US$) of Lebanon in 2009?
Ensure brevity in your answer.  2.30e+08. What is the difference between the Aid flow from UN agencies (US$) of Middle East & North Africa (developing only) in 2008 and the Aid flow from UN agencies (US$) of Jordan in 2009?
Make the answer very short. 3.55e+08. What is the difference between the Aid flow from UN agencies (US$) in Middle East & North Africa (developing only) in 2008 and the Aid flow from UN agencies (US$) in Lebanon in 2009?
Offer a very short reply. 4.06e+08. What is the difference between the Aid flow from UN agencies (US$) in Jordan in 2008 and the Aid flow from UN agencies (US$) in Lebanon in 2009?
Ensure brevity in your answer.  4.85e+07. What is the average Aid flow from UN agencies (US$) of Fragile and conflict affected situations per year?
Offer a terse response. 2.64e+08. What is the average Aid flow from UN agencies (US$) in Middle East & North Africa (developing only) per year?
Give a very brief answer. 4.19e+08. What is the average Aid flow from UN agencies (US$) in Jordan per year?
Make the answer very short. 9.92e+07. What is the average Aid flow from UN agencies (US$) of Lebanon per year?
Give a very brief answer. 5.59e+07. In the year 2003, what is the difference between the Aid flow from UN agencies (US$) in Fragile and conflict affected situations and Aid flow from UN agencies (US$) in Middle East & North Africa (developing only)?
Your answer should be very brief. -1.40e+08. In the year 2003, what is the difference between the Aid flow from UN agencies (US$) in Fragile and conflict affected situations and Aid flow from UN agencies (US$) in Jordan?
Give a very brief answer. 2.02e+08. In the year 2003, what is the difference between the Aid flow from UN agencies (US$) in Fragile and conflict affected situations and Aid flow from UN agencies (US$) in Lebanon?
Provide a succinct answer. 2.39e+08. In the year 2003, what is the difference between the Aid flow from UN agencies (US$) in Middle East & North Africa (developing only) and Aid flow from UN agencies (US$) in Jordan?
Ensure brevity in your answer.  3.41e+08. In the year 2003, what is the difference between the Aid flow from UN agencies (US$) of Middle East & North Africa (developing only) and Aid flow from UN agencies (US$) of Lebanon?
Offer a terse response. 3.79e+08. In the year 2003, what is the difference between the Aid flow from UN agencies (US$) in Jordan and Aid flow from UN agencies (US$) in Lebanon?
Your response must be concise. 3.76e+07. In the year 2004, what is the difference between the Aid flow from UN agencies (US$) in Fragile and conflict affected situations and Aid flow from UN agencies (US$) in Middle East & North Africa (developing only)?
Keep it short and to the point. -1.47e+08. In the year 2004, what is the difference between the Aid flow from UN agencies (US$) in Fragile and conflict affected situations and Aid flow from UN agencies (US$) in Jordan?
Offer a very short reply. 2.12e+08. In the year 2004, what is the difference between the Aid flow from UN agencies (US$) of Fragile and conflict affected situations and Aid flow from UN agencies (US$) of Lebanon?
Offer a very short reply. 2.44e+08. In the year 2004, what is the difference between the Aid flow from UN agencies (US$) in Middle East & North Africa (developing only) and Aid flow from UN agencies (US$) in Jordan?
Offer a very short reply. 3.59e+08. In the year 2004, what is the difference between the Aid flow from UN agencies (US$) of Middle East & North Africa (developing only) and Aid flow from UN agencies (US$) of Lebanon?
Your response must be concise. 3.91e+08. In the year 2004, what is the difference between the Aid flow from UN agencies (US$) of Jordan and Aid flow from UN agencies (US$) of Lebanon?
Your answer should be compact. 3.22e+07. In the year 2005, what is the difference between the Aid flow from UN agencies (US$) of Fragile and conflict affected situations and Aid flow from UN agencies (US$) of Middle East & North Africa (developing only)?
Make the answer very short. -1.44e+08. In the year 2005, what is the difference between the Aid flow from UN agencies (US$) of Fragile and conflict affected situations and Aid flow from UN agencies (US$) of Jordan?
Ensure brevity in your answer.  1.14e+08. In the year 2005, what is the difference between the Aid flow from UN agencies (US$) in Fragile and conflict affected situations and Aid flow from UN agencies (US$) in Lebanon?
Give a very brief answer. 1.55e+08. In the year 2005, what is the difference between the Aid flow from UN agencies (US$) of Middle East & North Africa (developing only) and Aid flow from UN agencies (US$) of Jordan?
Give a very brief answer. 2.58e+08. In the year 2005, what is the difference between the Aid flow from UN agencies (US$) of Middle East & North Africa (developing only) and Aid flow from UN agencies (US$) of Lebanon?
Provide a short and direct response. 2.99e+08. In the year 2005, what is the difference between the Aid flow from UN agencies (US$) in Jordan and Aid flow from UN agencies (US$) in Lebanon?
Give a very brief answer. 4.08e+07. In the year 2006, what is the difference between the Aid flow from UN agencies (US$) in Fragile and conflict affected situations and Aid flow from UN agencies (US$) in Middle East & North Africa (developing only)?
Ensure brevity in your answer.  -1.43e+08. In the year 2006, what is the difference between the Aid flow from UN agencies (US$) in Fragile and conflict affected situations and Aid flow from UN agencies (US$) in Jordan?
Your answer should be very brief. 1.37e+08. In the year 2006, what is the difference between the Aid flow from UN agencies (US$) in Fragile and conflict affected situations and Aid flow from UN agencies (US$) in Lebanon?
Ensure brevity in your answer.  1.77e+08. In the year 2006, what is the difference between the Aid flow from UN agencies (US$) of Middle East & North Africa (developing only) and Aid flow from UN agencies (US$) of Jordan?
Make the answer very short. 2.80e+08. In the year 2006, what is the difference between the Aid flow from UN agencies (US$) in Middle East & North Africa (developing only) and Aid flow from UN agencies (US$) in Lebanon?
Offer a terse response. 3.20e+08. In the year 2006, what is the difference between the Aid flow from UN agencies (US$) in Jordan and Aid flow from UN agencies (US$) in Lebanon?
Your answer should be very brief. 4.02e+07. In the year 2007, what is the difference between the Aid flow from UN agencies (US$) in Fragile and conflict affected situations and Aid flow from UN agencies (US$) in Middle East & North Africa (developing only)?
Keep it short and to the point. -1.51e+08. In the year 2007, what is the difference between the Aid flow from UN agencies (US$) of Fragile and conflict affected situations and Aid flow from UN agencies (US$) of Jordan?
Your answer should be very brief. 1.39e+08. In the year 2007, what is the difference between the Aid flow from UN agencies (US$) of Fragile and conflict affected situations and Aid flow from UN agencies (US$) of Lebanon?
Offer a terse response. 1.86e+08. In the year 2007, what is the difference between the Aid flow from UN agencies (US$) of Middle East & North Africa (developing only) and Aid flow from UN agencies (US$) of Jordan?
Offer a very short reply. 2.90e+08. In the year 2007, what is the difference between the Aid flow from UN agencies (US$) of Middle East & North Africa (developing only) and Aid flow from UN agencies (US$) of Lebanon?
Offer a terse response. 3.37e+08. In the year 2007, what is the difference between the Aid flow from UN agencies (US$) in Jordan and Aid flow from UN agencies (US$) in Lebanon?
Your answer should be compact. 4.70e+07. In the year 2008, what is the difference between the Aid flow from UN agencies (US$) in Fragile and conflict affected situations and Aid flow from UN agencies (US$) in Middle East & North Africa (developing only)?
Ensure brevity in your answer.  -1.76e+08. In the year 2008, what is the difference between the Aid flow from UN agencies (US$) in Fragile and conflict affected situations and Aid flow from UN agencies (US$) in Jordan?
Make the answer very short. 1.81e+08. In the year 2008, what is the difference between the Aid flow from UN agencies (US$) in Fragile and conflict affected situations and Aid flow from UN agencies (US$) in Lebanon?
Offer a very short reply. 2.36e+08. In the year 2008, what is the difference between the Aid flow from UN agencies (US$) of Middle East & North Africa (developing only) and Aid flow from UN agencies (US$) of Jordan?
Your response must be concise. 3.58e+08. In the year 2008, what is the difference between the Aid flow from UN agencies (US$) of Middle East & North Africa (developing only) and Aid flow from UN agencies (US$) of Lebanon?
Provide a succinct answer. 4.12e+08. In the year 2008, what is the difference between the Aid flow from UN agencies (US$) in Jordan and Aid flow from UN agencies (US$) in Lebanon?
Your response must be concise. 5.45e+07. In the year 2009, what is the difference between the Aid flow from UN agencies (US$) of Fragile and conflict affected situations and Aid flow from UN agencies (US$) of Middle East & North Africa (developing only)?
Ensure brevity in your answer.  -1.85e+08. In the year 2009, what is the difference between the Aid flow from UN agencies (US$) of Fragile and conflict affected situations and Aid flow from UN agencies (US$) of Jordan?
Make the answer very short. 1.70e+08. In the year 2009, what is the difference between the Aid flow from UN agencies (US$) in Fragile and conflict affected situations and Aid flow from UN agencies (US$) in Lebanon?
Your response must be concise. 2.21e+08. In the year 2009, what is the difference between the Aid flow from UN agencies (US$) in Middle East & North Africa (developing only) and Aid flow from UN agencies (US$) in Jordan?
Provide a short and direct response. 3.55e+08. In the year 2009, what is the difference between the Aid flow from UN agencies (US$) in Middle East & North Africa (developing only) and Aid flow from UN agencies (US$) in Lebanon?
Provide a succinct answer. 4.06e+08. In the year 2009, what is the difference between the Aid flow from UN agencies (US$) of Jordan and Aid flow from UN agencies (US$) of Lebanon?
Provide a succinct answer. 5.11e+07. What is the ratio of the Aid flow from UN agencies (US$) of Fragile and conflict affected situations in 2003 to that in 2004?
Your answer should be compact. 0.96. What is the ratio of the Aid flow from UN agencies (US$) in Jordan in 2003 to that in 2004?
Offer a terse response. 0.99. What is the ratio of the Aid flow from UN agencies (US$) of Lebanon in 2003 to that in 2004?
Make the answer very short. 0.89. What is the ratio of the Aid flow from UN agencies (US$) in Fragile and conflict affected situations in 2003 to that in 2005?
Your response must be concise. 1.41. What is the ratio of the Aid flow from UN agencies (US$) in Middle East & North Africa (developing only) in 2003 to that in 2005?
Keep it short and to the point. 1.23. What is the ratio of the Aid flow from UN agencies (US$) in Jordan in 2003 to that in 2005?
Give a very brief answer. 0.96. What is the ratio of the Aid flow from UN agencies (US$) of Lebanon in 2003 to that in 2005?
Offer a terse response. 0.99. What is the ratio of the Aid flow from UN agencies (US$) of Fragile and conflict affected situations in 2003 to that in 2006?
Your answer should be very brief. 1.27. What is the ratio of the Aid flow from UN agencies (US$) of Middle East & North Africa (developing only) in 2003 to that in 2006?
Give a very brief answer. 1.16. What is the ratio of the Aid flow from UN agencies (US$) in Jordan in 2003 to that in 2006?
Ensure brevity in your answer.  0.97. What is the ratio of the Aid flow from UN agencies (US$) of Lebanon in 2003 to that in 2006?
Your answer should be compact. 1. What is the ratio of the Aid flow from UN agencies (US$) in Fragile and conflict affected situations in 2003 to that in 2007?
Ensure brevity in your answer.  1.22. What is the ratio of the Aid flow from UN agencies (US$) in Middle East & North Africa (developing only) in 2003 to that in 2007?
Your answer should be very brief. 1.11. What is the ratio of the Aid flow from UN agencies (US$) in Jordan in 2003 to that in 2007?
Give a very brief answer. 0.9. What is the ratio of the Aid flow from UN agencies (US$) in Lebanon in 2003 to that in 2007?
Your answer should be compact. 0.98. What is the ratio of the Aid flow from UN agencies (US$) in Fragile and conflict affected situations in 2003 to that in 2008?
Provide a short and direct response. 0.98. What is the ratio of the Aid flow from UN agencies (US$) in Middle East & North Africa (developing only) in 2003 to that in 2008?
Offer a very short reply. 0.91. What is the ratio of the Aid flow from UN agencies (US$) in Jordan in 2003 to that in 2008?
Your answer should be very brief. 0.77. What is the ratio of the Aid flow from UN agencies (US$) in Lebanon in 2003 to that in 2008?
Your answer should be very brief. 0.84. What is the ratio of the Aid flow from UN agencies (US$) in Fragile and conflict affected situations in 2003 to that in 2009?
Your response must be concise. 1.01. What is the ratio of the Aid flow from UN agencies (US$) of Middle East & North Africa (developing only) in 2003 to that in 2009?
Your answer should be very brief. 0.91. What is the ratio of the Aid flow from UN agencies (US$) in Jordan in 2003 to that in 2009?
Your answer should be very brief. 0.75. What is the ratio of the Aid flow from UN agencies (US$) in Lebanon in 2003 to that in 2009?
Give a very brief answer. 0.76. What is the ratio of the Aid flow from UN agencies (US$) of Fragile and conflict affected situations in 2004 to that in 2005?
Your response must be concise. 1.46. What is the ratio of the Aid flow from UN agencies (US$) in Middle East & North Africa (developing only) in 2004 to that in 2005?
Keep it short and to the point. 1.28. What is the ratio of the Aid flow from UN agencies (US$) in Jordan in 2004 to that in 2005?
Your answer should be compact. 0.97. What is the ratio of the Aid flow from UN agencies (US$) in Lebanon in 2004 to that in 2005?
Ensure brevity in your answer.  1.12. What is the ratio of the Aid flow from UN agencies (US$) of Fragile and conflict affected situations in 2004 to that in 2006?
Make the answer very short. 1.32. What is the ratio of the Aid flow from UN agencies (US$) of Middle East & North Africa (developing only) in 2004 to that in 2006?
Your answer should be very brief. 1.21. What is the ratio of the Aid flow from UN agencies (US$) in Jordan in 2004 to that in 2006?
Your response must be concise. 0.98. What is the ratio of the Aid flow from UN agencies (US$) in Lebanon in 2004 to that in 2006?
Your answer should be compact. 1.12. What is the ratio of the Aid flow from UN agencies (US$) of Fragile and conflict affected situations in 2004 to that in 2007?
Your answer should be very brief. 1.27. What is the ratio of the Aid flow from UN agencies (US$) of Middle East & North Africa (developing only) in 2004 to that in 2007?
Your answer should be compact. 1.16. What is the ratio of the Aid flow from UN agencies (US$) in Jordan in 2004 to that in 2007?
Ensure brevity in your answer.  0.91. What is the ratio of the Aid flow from UN agencies (US$) in Lebanon in 2004 to that in 2007?
Make the answer very short. 1.11. What is the ratio of the Aid flow from UN agencies (US$) of Fragile and conflict affected situations in 2004 to that in 2008?
Ensure brevity in your answer.  1.02. What is the ratio of the Aid flow from UN agencies (US$) of Middle East & North Africa (developing only) in 2004 to that in 2008?
Your answer should be very brief. 0.95. What is the ratio of the Aid flow from UN agencies (US$) in Jordan in 2004 to that in 2008?
Offer a very short reply. 0.78. What is the ratio of the Aid flow from UN agencies (US$) in Lebanon in 2004 to that in 2008?
Your answer should be compact. 0.94. What is the ratio of the Aid flow from UN agencies (US$) in Fragile and conflict affected situations in 2004 to that in 2009?
Make the answer very short. 1.05. What is the ratio of the Aid flow from UN agencies (US$) of Middle East & North Africa (developing only) in 2004 to that in 2009?
Offer a very short reply. 0.95. What is the ratio of the Aid flow from UN agencies (US$) of Jordan in 2004 to that in 2009?
Your response must be concise. 0.76. What is the ratio of the Aid flow from UN agencies (US$) in Lebanon in 2004 to that in 2009?
Your answer should be very brief. 0.86. What is the ratio of the Aid flow from UN agencies (US$) in Fragile and conflict affected situations in 2005 to that in 2006?
Make the answer very short. 0.9. What is the ratio of the Aid flow from UN agencies (US$) in Middle East & North Africa (developing only) in 2005 to that in 2006?
Your response must be concise. 0.94. What is the ratio of the Aid flow from UN agencies (US$) of Jordan in 2005 to that in 2006?
Keep it short and to the point. 1.01. What is the ratio of the Aid flow from UN agencies (US$) in Fragile and conflict affected situations in 2005 to that in 2007?
Your answer should be compact. 0.87. What is the ratio of the Aid flow from UN agencies (US$) of Middle East & North Africa (developing only) in 2005 to that in 2007?
Your answer should be very brief. 0.9. What is the ratio of the Aid flow from UN agencies (US$) of Jordan in 2005 to that in 2007?
Your answer should be very brief. 0.93. What is the ratio of the Aid flow from UN agencies (US$) of Lebanon in 2005 to that in 2007?
Keep it short and to the point. 0.99. What is the ratio of the Aid flow from UN agencies (US$) in Fragile and conflict affected situations in 2005 to that in 2008?
Give a very brief answer. 0.7. What is the ratio of the Aid flow from UN agencies (US$) in Middle East & North Africa (developing only) in 2005 to that in 2008?
Your answer should be very brief. 0.74. What is the ratio of the Aid flow from UN agencies (US$) of Jordan in 2005 to that in 2008?
Make the answer very short. 0.8. What is the ratio of the Aid flow from UN agencies (US$) in Lebanon in 2005 to that in 2008?
Provide a succinct answer. 0.84. What is the ratio of the Aid flow from UN agencies (US$) of Fragile and conflict affected situations in 2005 to that in 2009?
Your answer should be very brief. 0.72. What is the ratio of the Aid flow from UN agencies (US$) of Middle East & North Africa (developing only) in 2005 to that in 2009?
Ensure brevity in your answer.  0.74. What is the ratio of the Aid flow from UN agencies (US$) in Jordan in 2005 to that in 2009?
Keep it short and to the point. 0.78. What is the ratio of the Aid flow from UN agencies (US$) in Lebanon in 2005 to that in 2009?
Give a very brief answer. 0.77. What is the ratio of the Aid flow from UN agencies (US$) in Fragile and conflict affected situations in 2006 to that in 2007?
Ensure brevity in your answer.  0.96. What is the ratio of the Aid flow from UN agencies (US$) of Middle East & North Africa (developing only) in 2006 to that in 2007?
Provide a short and direct response. 0.96. What is the ratio of the Aid flow from UN agencies (US$) in Jordan in 2006 to that in 2007?
Offer a terse response. 0.93. What is the ratio of the Aid flow from UN agencies (US$) of Lebanon in 2006 to that in 2007?
Offer a very short reply. 0.99. What is the ratio of the Aid flow from UN agencies (US$) of Fragile and conflict affected situations in 2006 to that in 2008?
Keep it short and to the point. 0.77. What is the ratio of the Aid flow from UN agencies (US$) in Middle East & North Africa (developing only) in 2006 to that in 2008?
Your answer should be compact. 0.79. What is the ratio of the Aid flow from UN agencies (US$) in Jordan in 2006 to that in 2008?
Your response must be concise. 0.79. What is the ratio of the Aid flow from UN agencies (US$) of Lebanon in 2006 to that in 2008?
Give a very brief answer. 0.84. What is the ratio of the Aid flow from UN agencies (US$) of Fragile and conflict affected situations in 2006 to that in 2009?
Your response must be concise. 0.8. What is the ratio of the Aid flow from UN agencies (US$) of Middle East & North Africa (developing only) in 2006 to that in 2009?
Your answer should be very brief. 0.79. What is the ratio of the Aid flow from UN agencies (US$) of Jordan in 2006 to that in 2009?
Offer a terse response. 0.78. What is the ratio of the Aid flow from UN agencies (US$) in Lebanon in 2006 to that in 2009?
Your answer should be very brief. 0.77. What is the ratio of the Aid flow from UN agencies (US$) of Fragile and conflict affected situations in 2007 to that in 2008?
Ensure brevity in your answer.  0.8. What is the ratio of the Aid flow from UN agencies (US$) of Middle East & North Africa (developing only) in 2007 to that in 2008?
Offer a very short reply. 0.82. What is the ratio of the Aid flow from UN agencies (US$) of Jordan in 2007 to that in 2008?
Keep it short and to the point. 0.86. What is the ratio of the Aid flow from UN agencies (US$) of Lebanon in 2007 to that in 2008?
Provide a succinct answer. 0.85. What is the ratio of the Aid flow from UN agencies (US$) in Fragile and conflict affected situations in 2007 to that in 2009?
Make the answer very short. 0.83. What is the ratio of the Aid flow from UN agencies (US$) of Middle East & North Africa (developing only) in 2007 to that in 2009?
Provide a succinct answer. 0.82. What is the ratio of the Aid flow from UN agencies (US$) in Jordan in 2007 to that in 2009?
Offer a very short reply. 0.84. What is the ratio of the Aid flow from UN agencies (US$) of Lebanon in 2007 to that in 2009?
Make the answer very short. 0.77. What is the ratio of the Aid flow from UN agencies (US$) in Fragile and conflict affected situations in 2008 to that in 2009?
Provide a succinct answer. 1.03. What is the ratio of the Aid flow from UN agencies (US$) in Middle East & North Africa (developing only) in 2008 to that in 2009?
Your response must be concise. 1. What is the ratio of the Aid flow from UN agencies (US$) in Jordan in 2008 to that in 2009?
Provide a succinct answer. 0.98. What is the ratio of the Aid flow from UN agencies (US$) of Lebanon in 2008 to that in 2009?
Your response must be concise. 0.91. What is the difference between the highest and the second highest Aid flow from UN agencies (US$) in Fragile and conflict affected situations?
Your response must be concise. 4.86e+06. What is the difference between the highest and the second highest Aid flow from UN agencies (US$) of Middle East & North Africa (developing only)?
Offer a terse response. 3.60e+05. What is the difference between the highest and the second highest Aid flow from UN agencies (US$) of Jordan?
Your answer should be very brief. 2.61e+06. What is the difference between the highest and the second highest Aid flow from UN agencies (US$) of Lebanon?
Provide a succinct answer. 6.08e+06. What is the difference between the highest and the lowest Aid flow from UN agencies (US$) in Fragile and conflict affected situations?
Ensure brevity in your answer.  9.53e+07. What is the difference between the highest and the lowest Aid flow from UN agencies (US$) in Middle East & North Africa (developing only)?
Your answer should be very brief. 1.23e+08. What is the difference between the highest and the lowest Aid flow from UN agencies (US$) of Jordan?
Provide a short and direct response. 2.94e+07. What is the difference between the highest and the lowest Aid flow from UN agencies (US$) of Lebanon?
Provide a succinct answer. 1.59e+07. 